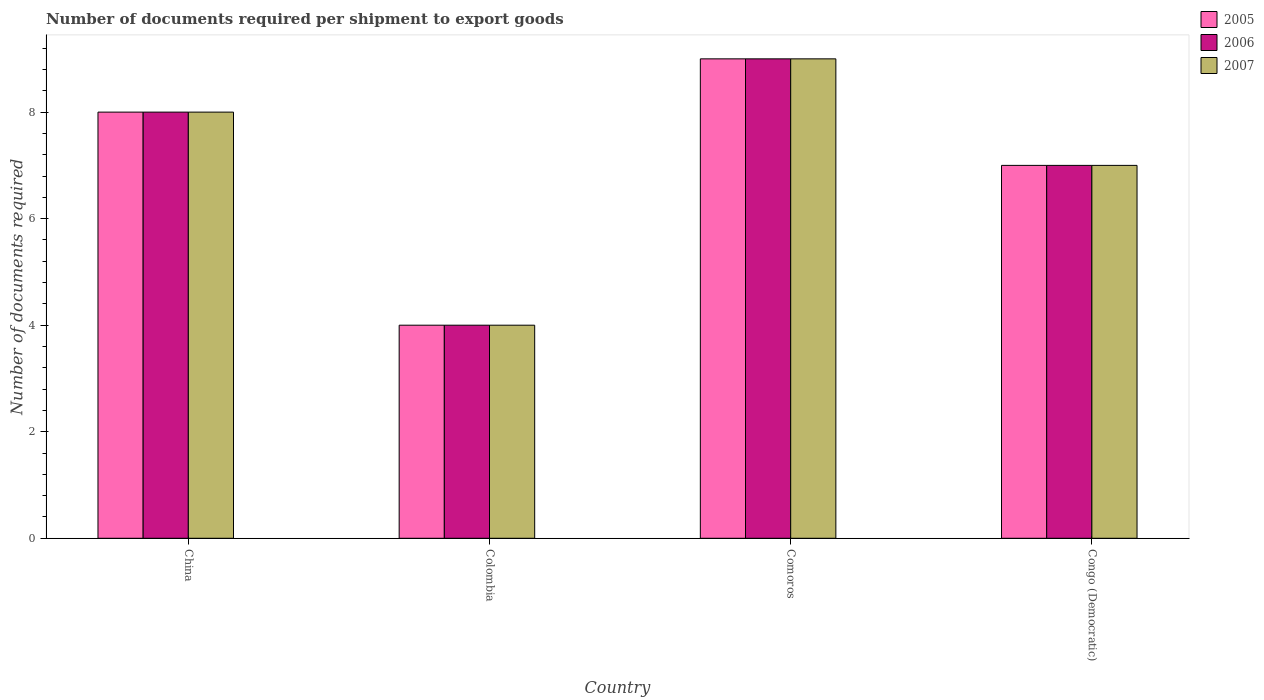How many groups of bars are there?
Give a very brief answer. 4. What is the label of the 3rd group of bars from the left?
Your response must be concise. Comoros. In how many cases, is the number of bars for a given country not equal to the number of legend labels?
Provide a short and direct response. 0. What is the number of documents required per shipment to export goods in 2007 in Comoros?
Ensure brevity in your answer.  9. Across all countries, what is the minimum number of documents required per shipment to export goods in 2007?
Give a very brief answer. 4. In which country was the number of documents required per shipment to export goods in 2005 maximum?
Give a very brief answer. Comoros. In which country was the number of documents required per shipment to export goods in 2007 minimum?
Your answer should be very brief. Colombia. What is the total number of documents required per shipment to export goods in 2007 in the graph?
Your answer should be compact. 28. What is the average number of documents required per shipment to export goods in 2007 per country?
Give a very brief answer. 7. What is the difference between the number of documents required per shipment to export goods of/in 2007 and number of documents required per shipment to export goods of/in 2006 in Congo (Democratic)?
Provide a short and direct response. 0. In how many countries, is the number of documents required per shipment to export goods in 2005 greater than 7.2?
Make the answer very short. 2. What is the ratio of the number of documents required per shipment to export goods in 2007 in Colombia to that in Comoros?
Make the answer very short. 0.44. Is the number of documents required per shipment to export goods in 2006 in Comoros less than that in Congo (Democratic)?
Your answer should be compact. No. What is the difference between the highest and the lowest number of documents required per shipment to export goods in 2006?
Ensure brevity in your answer.  5. Is the sum of the number of documents required per shipment to export goods in 2005 in China and Colombia greater than the maximum number of documents required per shipment to export goods in 2007 across all countries?
Your answer should be compact. Yes. Is it the case that in every country, the sum of the number of documents required per shipment to export goods in 2006 and number of documents required per shipment to export goods in 2005 is greater than the number of documents required per shipment to export goods in 2007?
Your answer should be very brief. Yes. What is the difference between two consecutive major ticks on the Y-axis?
Offer a terse response. 2. Does the graph contain any zero values?
Keep it short and to the point. No. Does the graph contain grids?
Offer a terse response. No. Where does the legend appear in the graph?
Your answer should be compact. Top right. How many legend labels are there?
Offer a terse response. 3. How are the legend labels stacked?
Your answer should be very brief. Vertical. What is the title of the graph?
Give a very brief answer. Number of documents required per shipment to export goods. Does "1978" appear as one of the legend labels in the graph?
Provide a short and direct response. No. What is the label or title of the X-axis?
Provide a succinct answer. Country. What is the label or title of the Y-axis?
Your response must be concise. Number of documents required. What is the Number of documents required of 2006 in China?
Provide a short and direct response. 8. What is the Number of documents required in 2007 in China?
Your response must be concise. 8. What is the Number of documents required of 2006 in Colombia?
Provide a short and direct response. 4. What is the Number of documents required of 2007 in Colombia?
Offer a very short reply. 4. What is the Number of documents required in 2005 in Comoros?
Offer a very short reply. 9. What is the Number of documents required of 2007 in Comoros?
Ensure brevity in your answer.  9. Across all countries, what is the maximum Number of documents required in 2005?
Give a very brief answer. 9. Across all countries, what is the minimum Number of documents required in 2005?
Ensure brevity in your answer.  4. Across all countries, what is the minimum Number of documents required in 2007?
Offer a very short reply. 4. What is the total Number of documents required in 2005 in the graph?
Provide a short and direct response. 28. What is the total Number of documents required of 2006 in the graph?
Offer a terse response. 28. What is the difference between the Number of documents required in 2006 in China and that in Colombia?
Your answer should be very brief. 4. What is the difference between the Number of documents required of 2005 in China and that in Comoros?
Offer a terse response. -1. What is the difference between the Number of documents required in 2006 in China and that in Comoros?
Provide a succinct answer. -1. What is the difference between the Number of documents required of 2005 in China and that in Congo (Democratic)?
Provide a short and direct response. 1. What is the difference between the Number of documents required of 2006 in China and that in Congo (Democratic)?
Ensure brevity in your answer.  1. What is the difference between the Number of documents required of 2007 in China and that in Congo (Democratic)?
Your response must be concise. 1. What is the difference between the Number of documents required in 2006 in Colombia and that in Comoros?
Your answer should be compact. -5. What is the difference between the Number of documents required of 2006 in Colombia and that in Congo (Democratic)?
Ensure brevity in your answer.  -3. What is the difference between the Number of documents required in 2005 in Comoros and that in Congo (Democratic)?
Offer a terse response. 2. What is the difference between the Number of documents required of 2007 in Comoros and that in Congo (Democratic)?
Ensure brevity in your answer.  2. What is the difference between the Number of documents required in 2005 in China and the Number of documents required in 2006 in Colombia?
Ensure brevity in your answer.  4. What is the difference between the Number of documents required in 2005 in China and the Number of documents required in 2007 in Colombia?
Keep it short and to the point. 4. What is the difference between the Number of documents required in 2006 in China and the Number of documents required in 2007 in Colombia?
Offer a very short reply. 4. What is the difference between the Number of documents required of 2005 in China and the Number of documents required of 2007 in Comoros?
Make the answer very short. -1. What is the difference between the Number of documents required in 2005 in China and the Number of documents required in 2007 in Congo (Democratic)?
Make the answer very short. 1. What is the difference between the Number of documents required of 2006 in China and the Number of documents required of 2007 in Congo (Democratic)?
Make the answer very short. 1. What is the difference between the Number of documents required in 2005 in Colombia and the Number of documents required in 2006 in Comoros?
Offer a very short reply. -5. What is the difference between the Number of documents required in 2005 in Colombia and the Number of documents required in 2007 in Comoros?
Make the answer very short. -5. What is the difference between the Number of documents required of 2006 in Colombia and the Number of documents required of 2007 in Congo (Democratic)?
Your answer should be very brief. -3. What is the difference between the Number of documents required of 2005 in Comoros and the Number of documents required of 2007 in Congo (Democratic)?
Provide a short and direct response. 2. What is the difference between the Number of documents required in 2006 in Comoros and the Number of documents required in 2007 in Congo (Democratic)?
Your answer should be very brief. 2. What is the average Number of documents required in 2005 per country?
Give a very brief answer. 7. What is the average Number of documents required in 2006 per country?
Provide a short and direct response. 7. What is the average Number of documents required in 2007 per country?
Make the answer very short. 7. What is the difference between the Number of documents required of 2005 and Number of documents required of 2006 in China?
Provide a short and direct response. 0. What is the difference between the Number of documents required in 2005 and Number of documents required in 2006 in Comoros?
Provide a short and direct response. 0. What is the ratio of the Number of documents required in 2007 in China to that in Colombia?
Provide a succinct answer. 2. What is the ratio of the Number of documents required in 2005 in China to that in Comoros?
Offer a very short reply. 0.89. What is the ratio of the Number of documents required of 2005 in China to that in Congo (Democratic)?
Provide a succinct answer. 1.14. What is the ratio of the Number of documents required in 2007 in China to that in Congo (Democratic)?
Your response must be concise. 1.14. What is the ratio of the Number of documents required in 2005 in Colombia to that in Comoros?
Provide a succinct answer. 0.44. What is the ratio of the Number of documents required in 2006 in Colombia to that in Comoros?
Keep it short and to the point. 0.44. What is the ratio of the Number of documents required of 2007 in Colombia to that in Comoros?
Offer a very short reply. 0.44. What is the ratio of the Number of documents required in 2005 in Colombia to that in Congo (Democratic)?
Offer a terse response. 0.57. What is the ratio of the Number of documents required in 2005 in Comoros to that in Congo (Democratic)?
Keep it short and to the point. 1.29. What is the ratio of the Number of documents required of 2006 in Comoros to that in Congo (Democratic)?
Keep it short and to the point. 1.29. What is the ratio of the Number of documents required in 2007 in Comoros to that in Congo (Democratic)?
Offer a very short reply. 1.29. What is the difference between the highest and the second highest Number of documents required in 2005?
Ensure brevity in your answer.  1. What is the difference between the highest and the second highest Number of documents required of 2006?
Your response must be concise. 1. What is the difference between the highest and the second highest Number of documents required of 2007?
Offer a terse response. 1. 